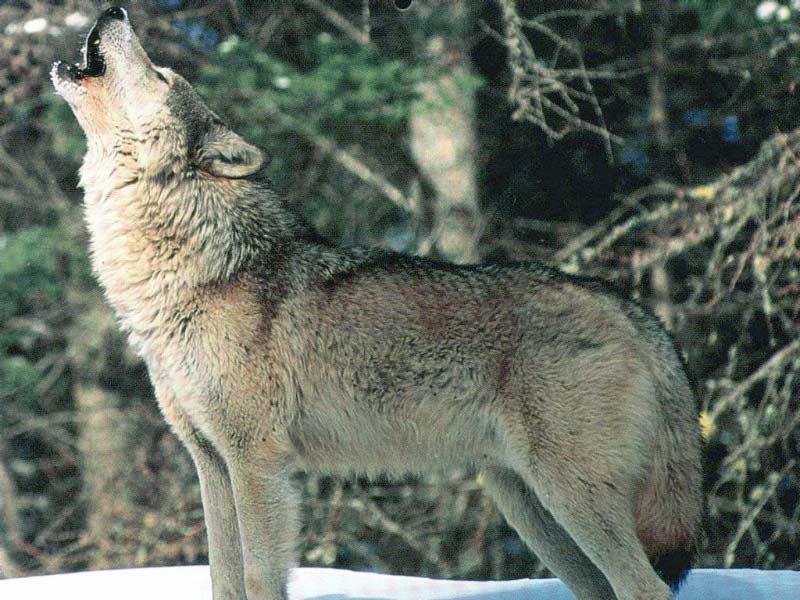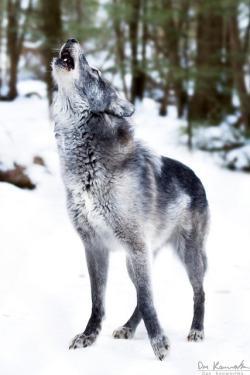The first image is the image on the left, the second image is the image on the right. For the images shown, is this caption "Each dog is howling in the snow." true? Answer yes or no. Yes. The first image is the image on the left, the second image is the image on the right. Analyze the images presented: Is the assertion "All wolves are howling, all scenes contain snow, and no image contains more than one wolf." valid? Answer yes or no. Yes. 